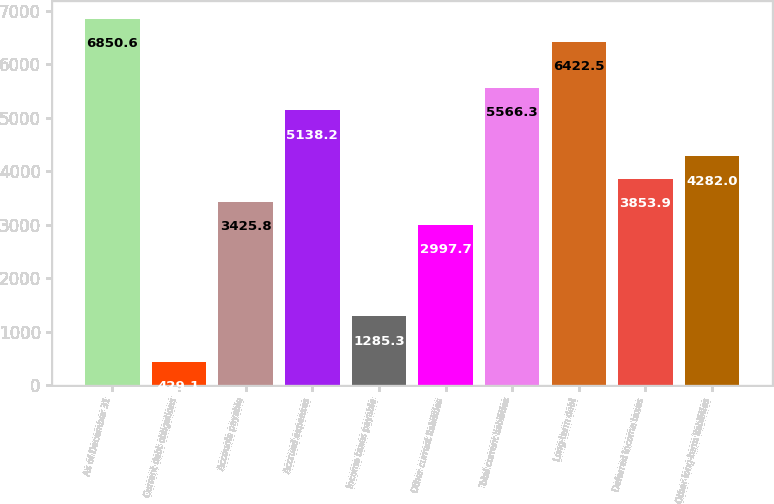<chart> <loc_0><loc_0><loc_500><loc_500><bar_chart><fcel>As of December 31<fcel>Current debt obligations<fcel>Accounts payable<fcel>Accrued expenses<fcel>Income taxes payable<fcel>Other current liabilities<fcel>Total current liabilities<fcel>Long-term debt<fcel>Deferred income taxes<fcel>Other long-term liabilities<nl><fcel>6850.6<fcel>429.1<fcel>3425.8<fcel>5138.2<fcel>1285.3<fcel>2997.7<fcel>5566.3<fcel>6422.5<fcel>3853.9<fcel>4282<nl></chart> 